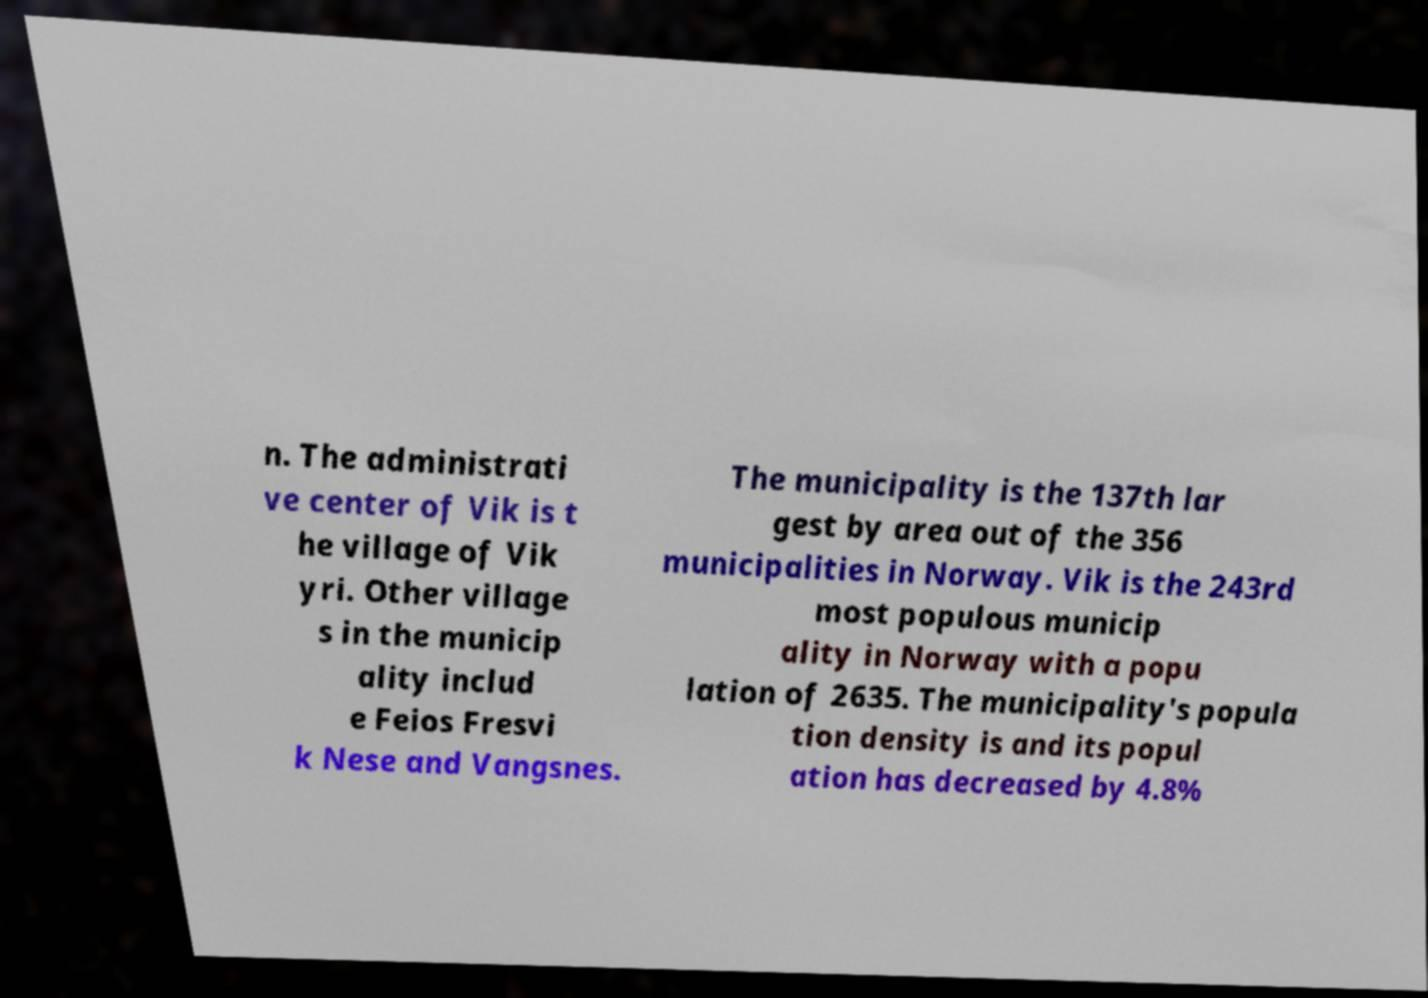Could you extract and type out the text from this image? n. The administrati ve center of Vik is t he village of Vik yri. Other village s in the municip ality includ e Feios Fresvi k Nese and Vangsnes. The municipality is the 137th lar gest by area out of the 356 municipalities in Norway. Vik is the 243rd most populous municip ality in Norway with a popu lation of 2635. The municipality's popula tion density is and its popul ation has decreased by 4.8% 